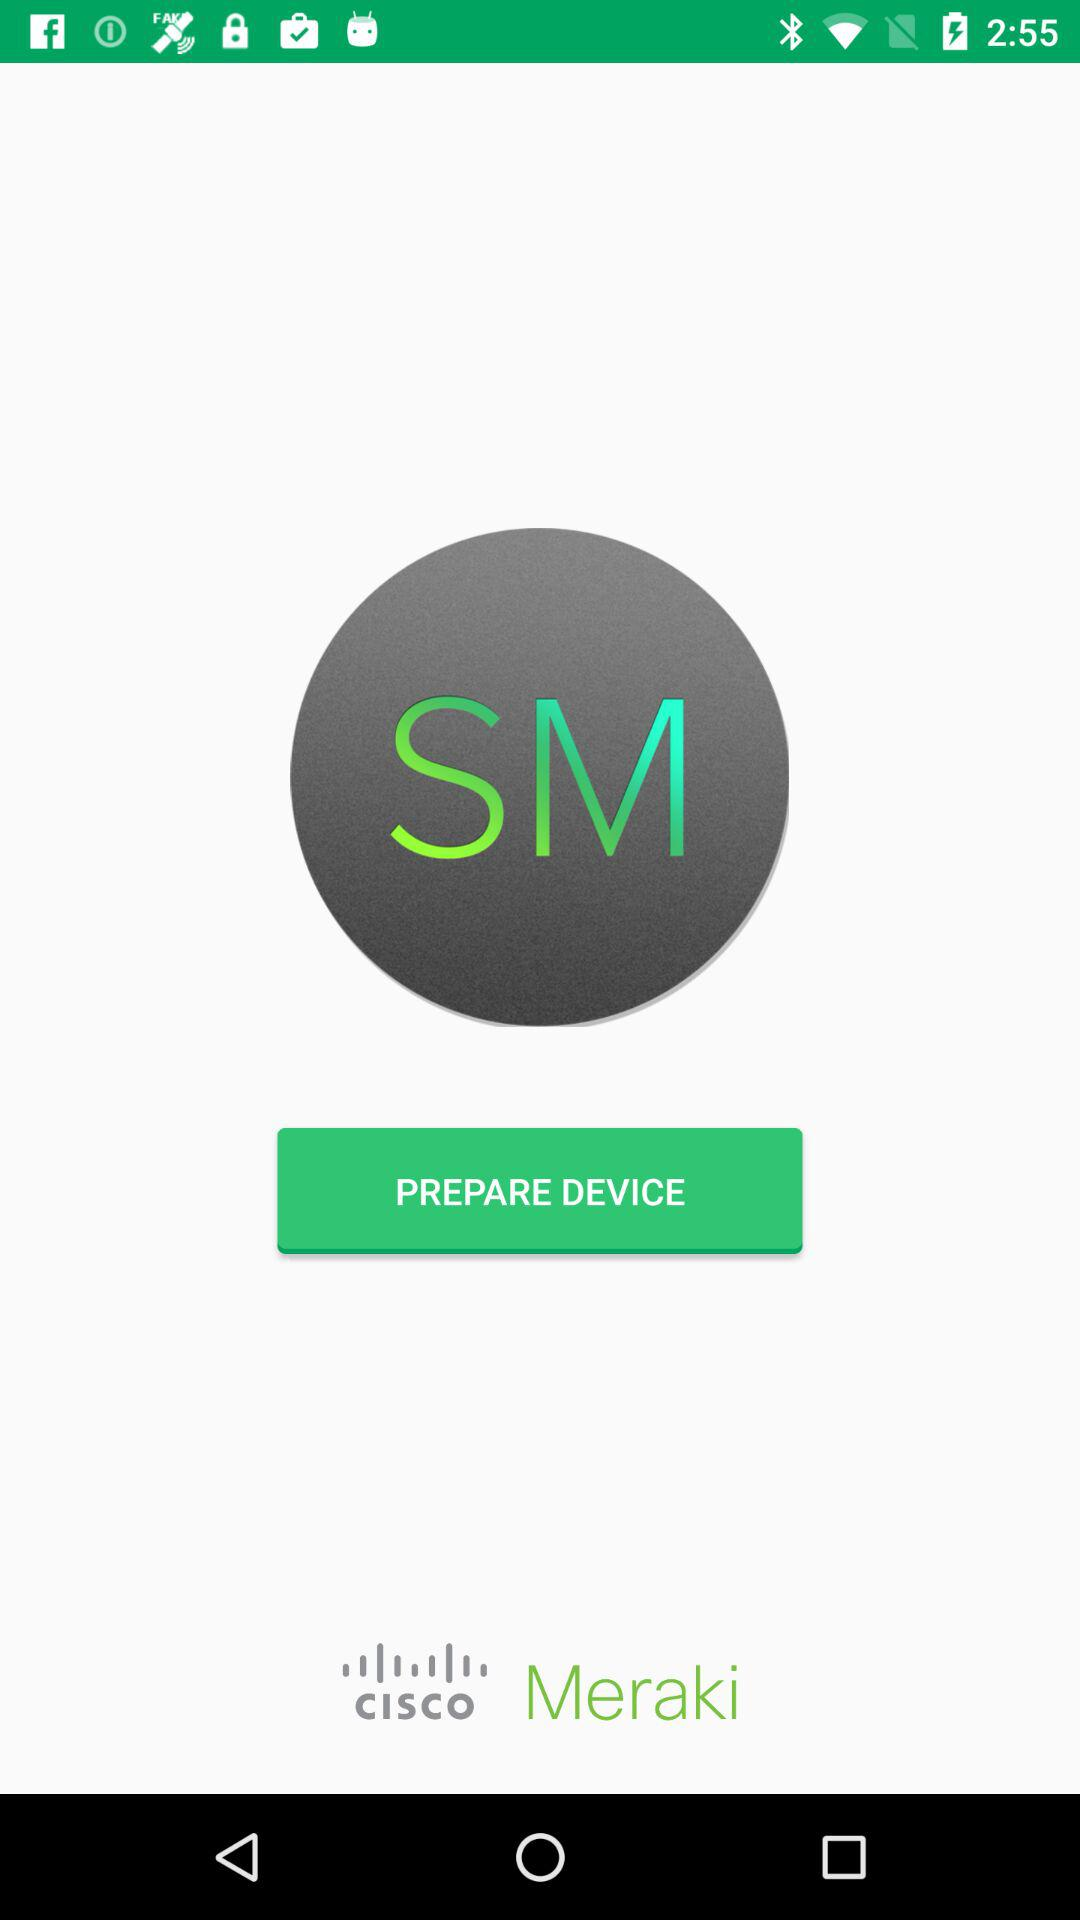What is the application name? The application name is "Meraki Systems Manager". 